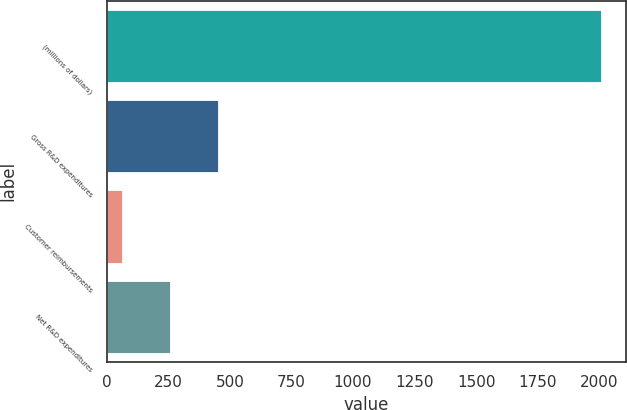Convert chart. <chart><loc_0><loc_0><loc_500><loc_500><bar_chart><fcel>(millions of dollars)<fcel>Gross R&D expenditures<fcel>Customer reimbursements<fcel>Net R&D expenditures<nl><fcel>2009<fcel>452.84<fcel>63.8<fcel>258.32<nl></chart> 